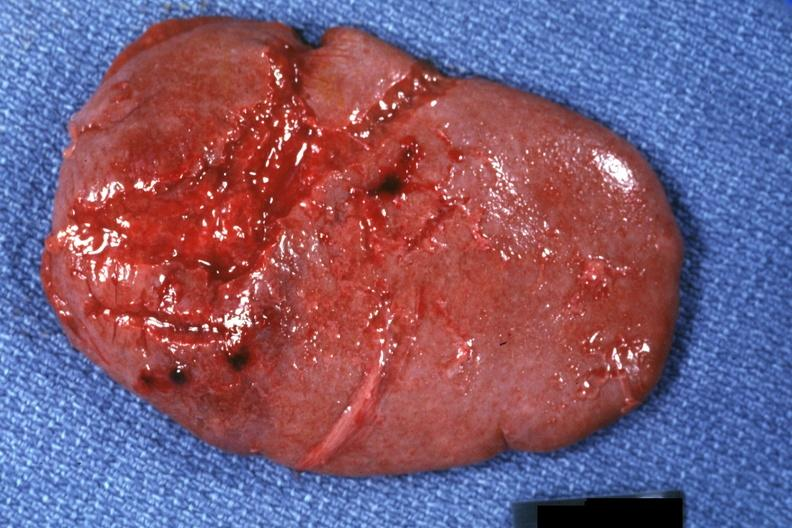what is present?
Answer the question using a single word or phrase. Spleen 